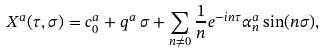Convert formula to latex. <formula><loc_0><loc_0><loc_500><loc_500>& X ^ { a } ( \tau , \sigma ) = c ^ { a } _ { 0 } + q ^ { a } \, \sigma + \sum _ { n \neq 0 } \frac { 1 } { n } e ^ { - i n \tau } \alpha ^ { a } _ { n } \sin ( n \sigma ) ,</formula> 